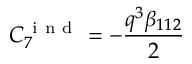Convert formula to latex. <formula><loc_0><loc_0><loc_500><loc_500>C _ { 7 } ^ { i n d } = - \frac { q ^ { 3 } \beta _ { 1 1 2 } } { 2 }</formula> 